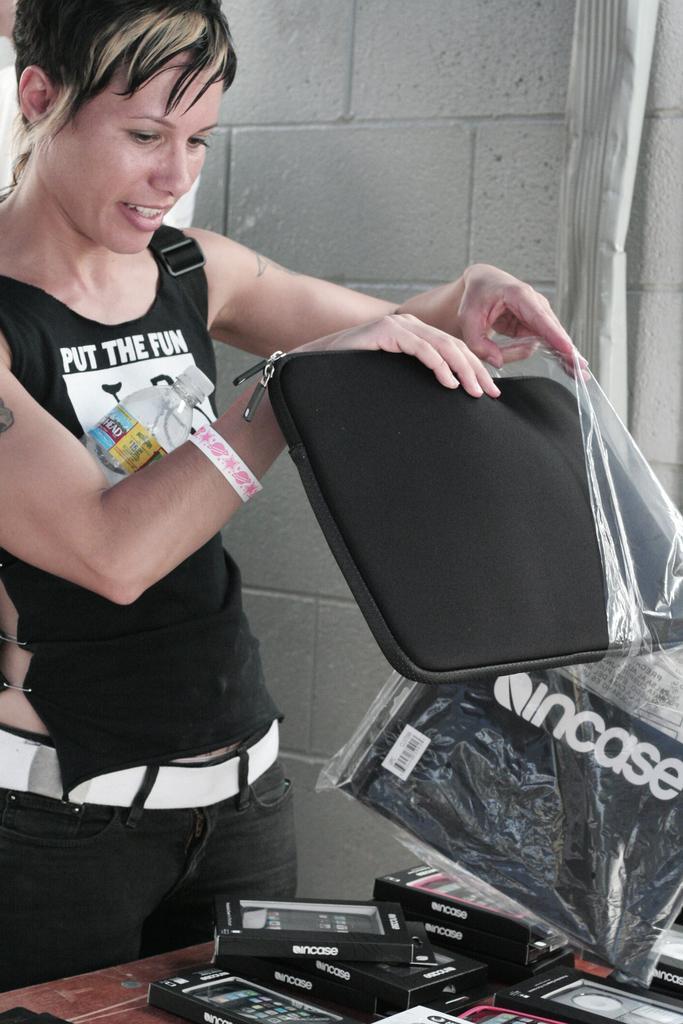In one or two sentences, can you explain what this image depicts? In this picture there is a girl who is standing on the left side of the image, by holding a bag in her hands, there is a table in front of her which contains boxes on it. 